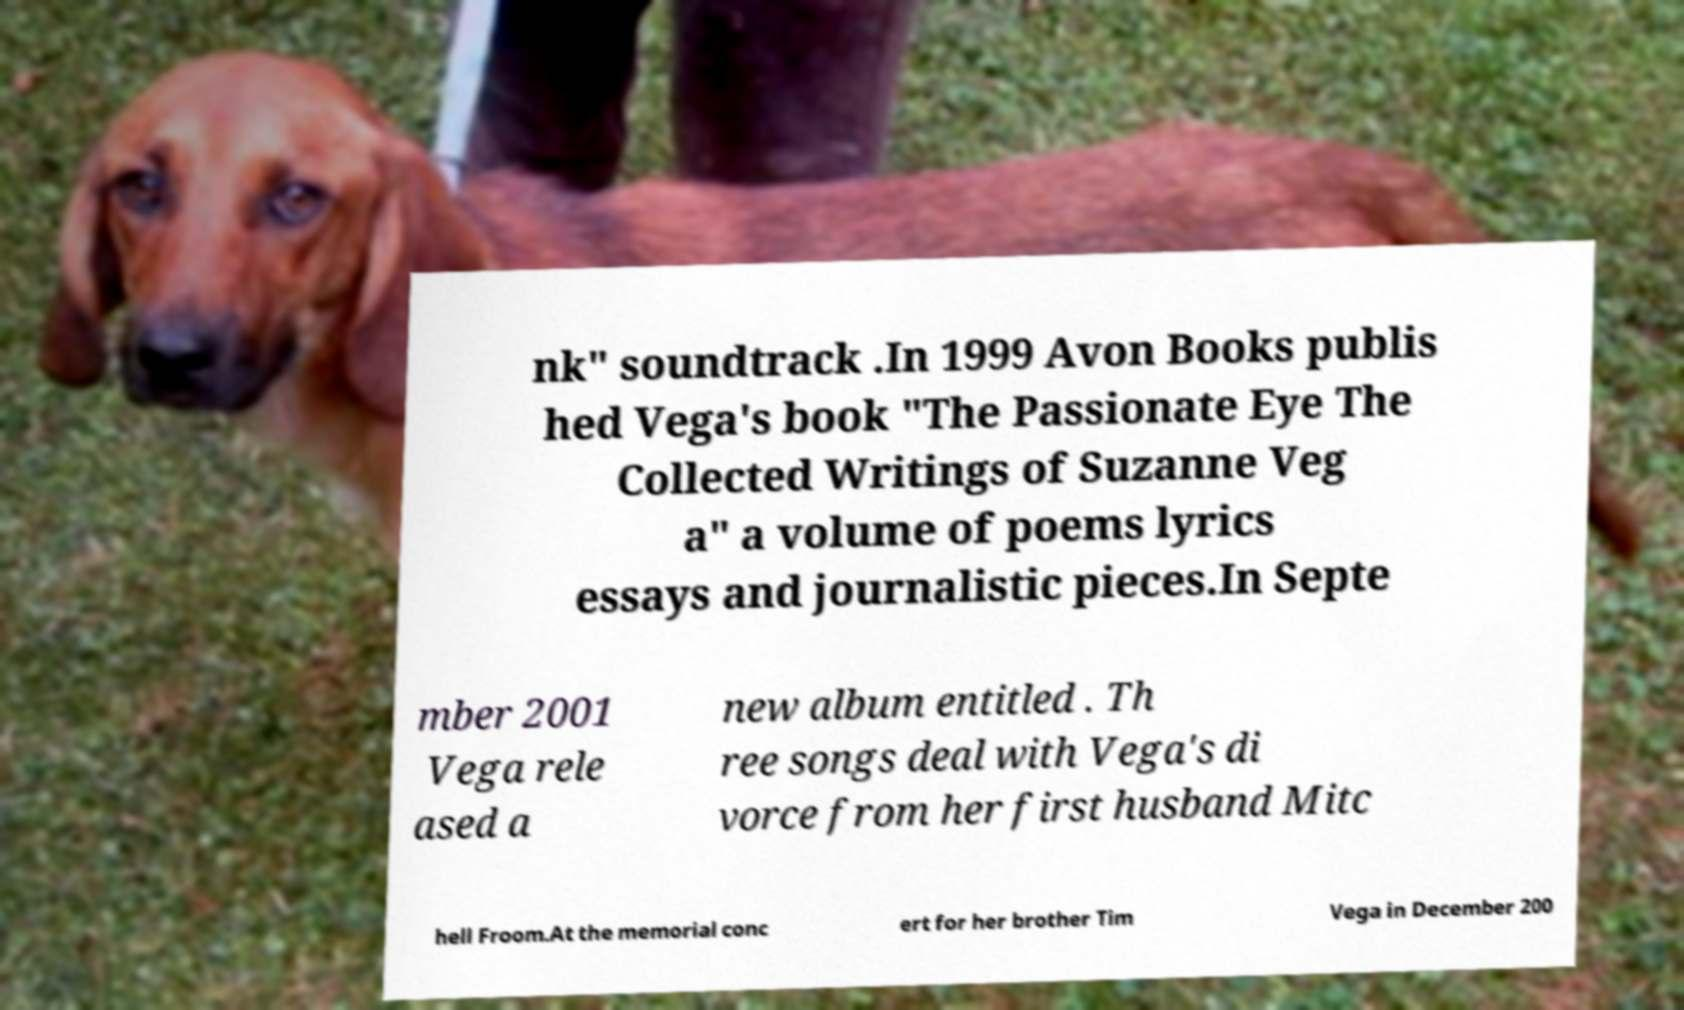Please read and relay the text visible in this image. What does it say? nk" soundtrack .In 1999 Avon Books publis hed Vega's book "The Passionate Eye The Collected Writings of Suzanne Veg a" a volume of poems lyrics essays and journalistic pieces.In Septe mber 2001 Vega rele ased a new album entitled . Th ree songs deal with Vega's di vorce from her first husband Mitc hell Froom.At the memorial conc ert for her brother Tim Vega in December 200 